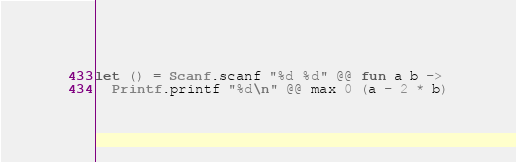<code> <loc_0><loc_0><loc_500><loc_500><_OCaml_>let () = Scanf.scanf "%d %d" @@ fun a b ->
  Printf.printf "%d\n" @@ max 0 (a - 2 * b)
</code> 